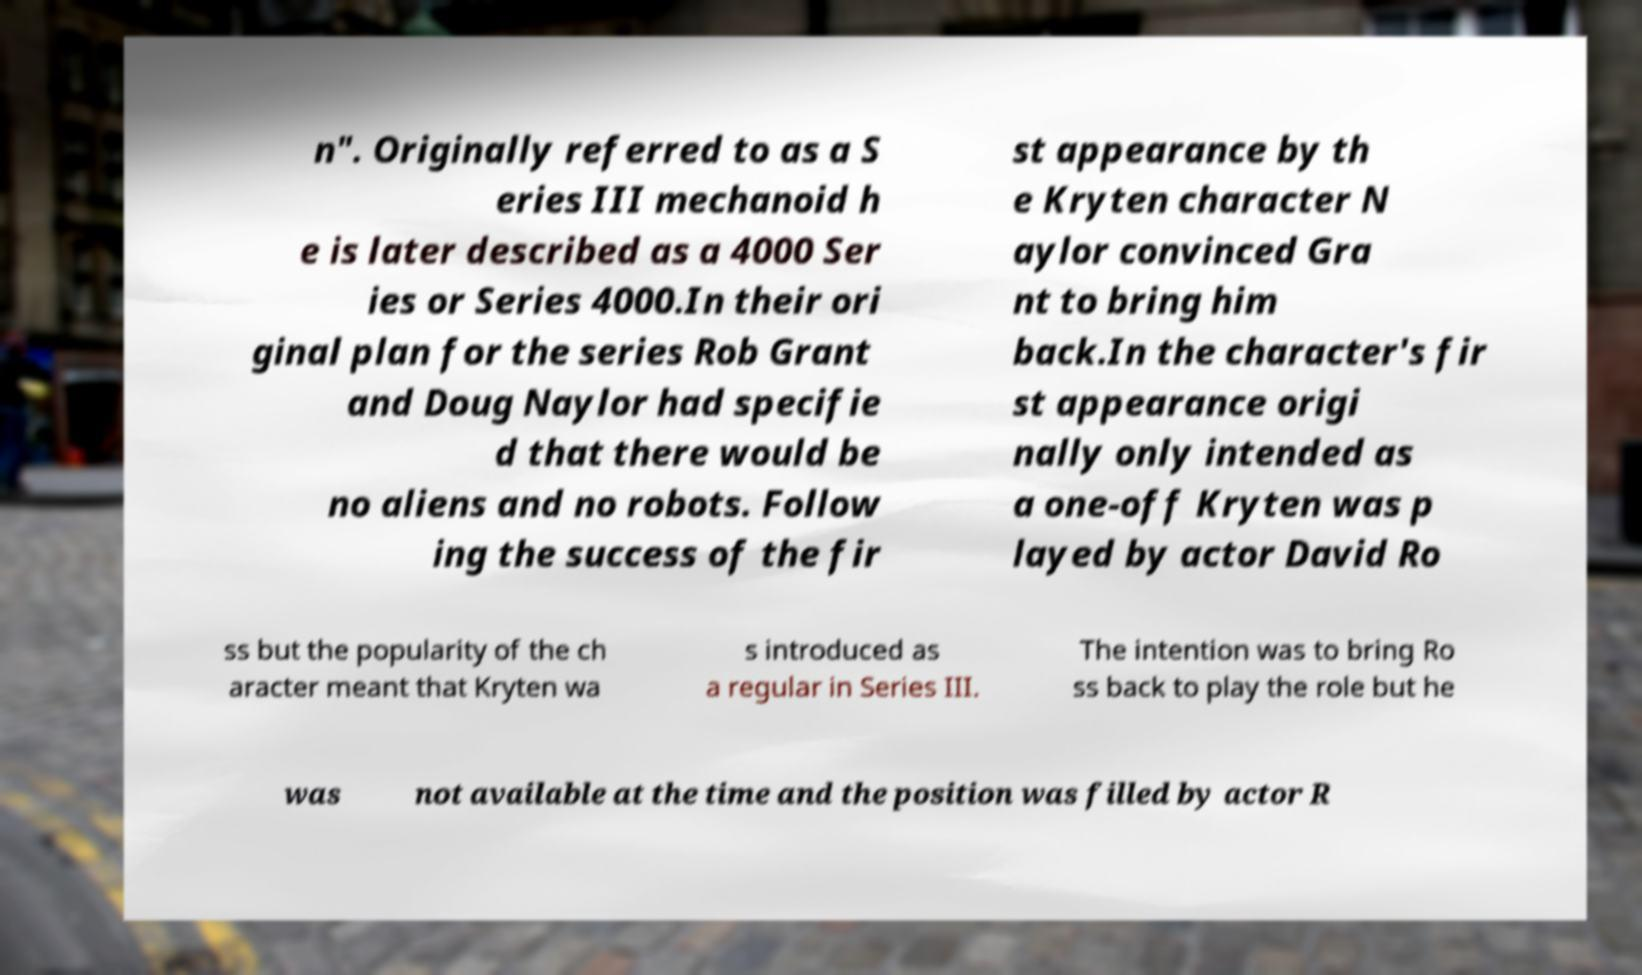Could you extract and type out the text from this image? n". Originally referred to as a S eries III mechanoid h e is later described as a 4000 Ser ies or Series 4000.In their ori ginal plan for the series Rob Grant and Doug Naylor had specifie d that there would be no aliens and no robots. Follow ing the success of the fir st appearance by th e Kryten character N aylor convinced Gra nt to bring him back.In the character's fir st appearance origi nally only intended as a one-off Kryten was p layed by actor David Ro ss but the popularity of the ch aracter meant that Kryten wa s introduced as a regular in Series III. The intention was to bring Ro ss back to play the role but he was not available at the time and the position was filled by actor R 